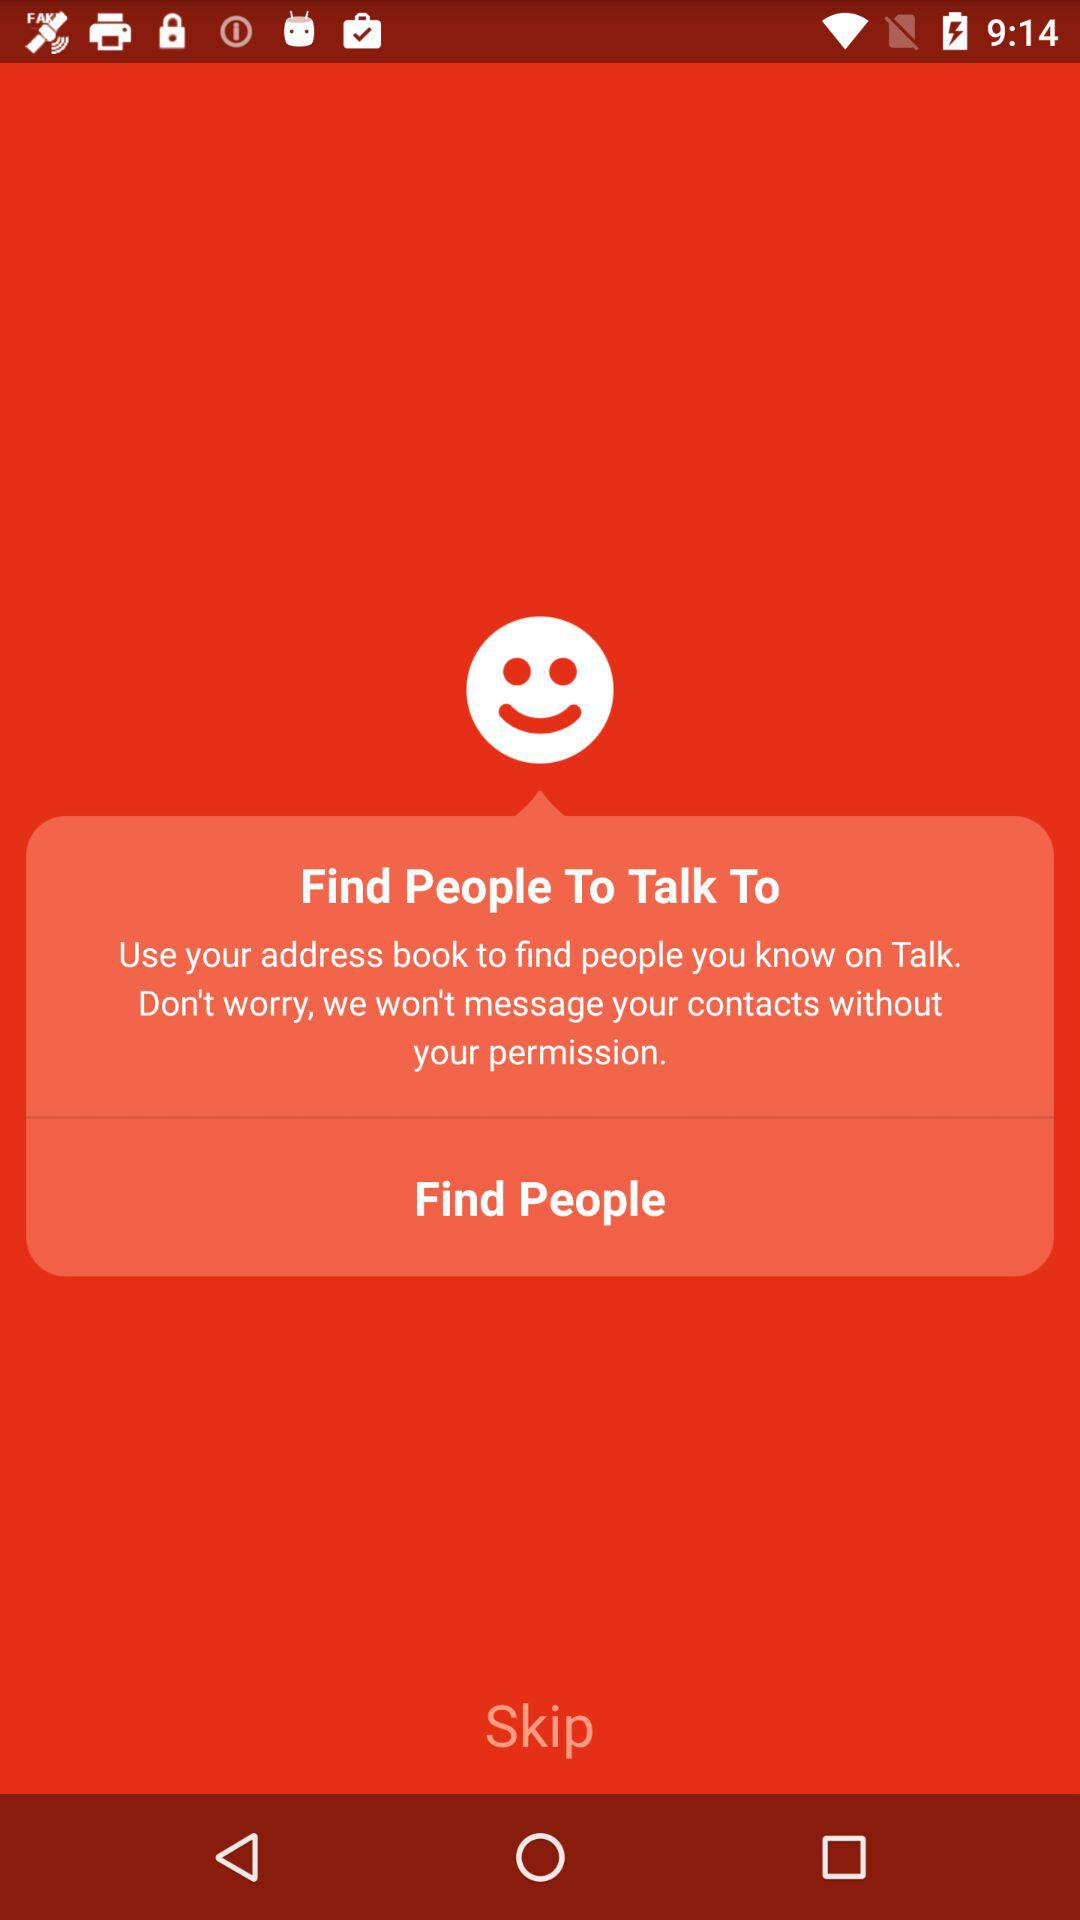What is the application name? The application name is "Talk". 